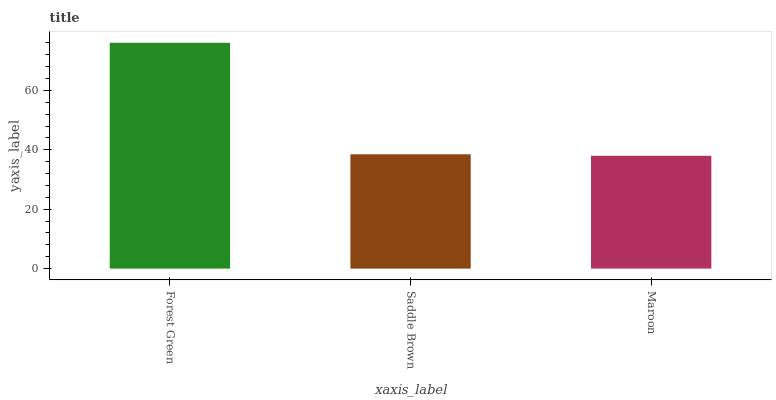Is Saddle Brown the minimum?
Answer yes or no. No. Is Saddle Brown the maximum?
Answer yes or no. No. Is Forest Green greater than Saddle Brown?
Answer yes or no. Yes. Is Saddle Brown less than Forest Green?
Answer yes or no. Yes. Is Saddle Brown greater than Forest Green?
Answer yes or no. No. Is Forest Green less than Saddle Brown?
Answer yes or no. No. Is Saddle Brown the high median?
Answer yes or no. Yes. Is Saddle Brown the low median?
Answer yes or no. Yes. Is Forest Green the high median?
Answer yes or no. No. Is Maroon the low median?
Answer yes or no. No. 